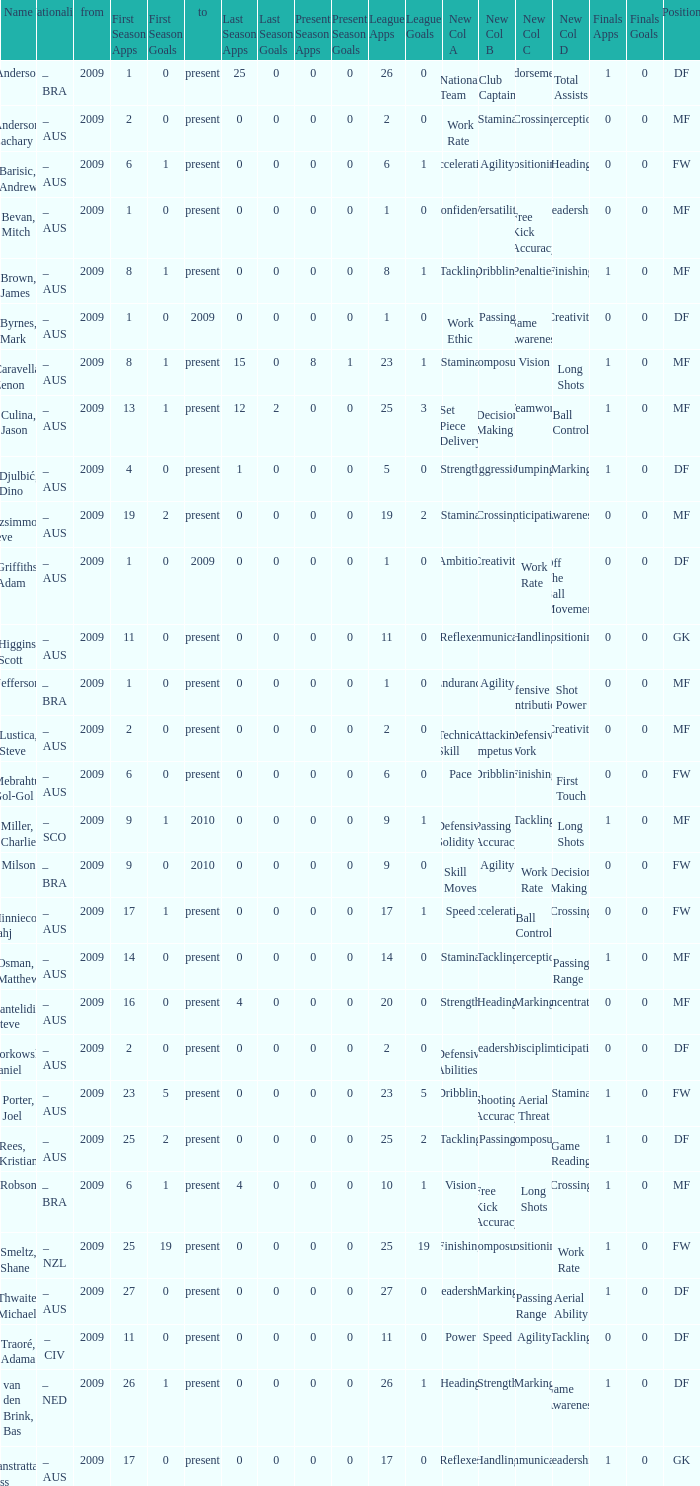Name the mosst finals apps 1.0. 